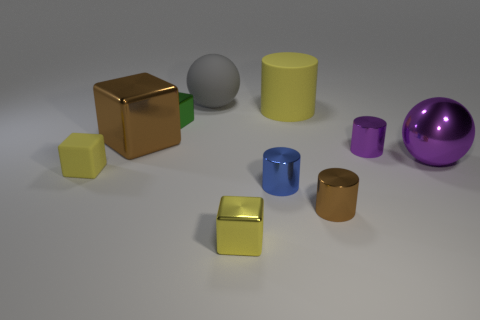How many objects are there in total? There are a total of eight objects. This includes three cubes, two cylinders, a sphere, and two smaller, cube-like objects, one of which is on top of the other. 